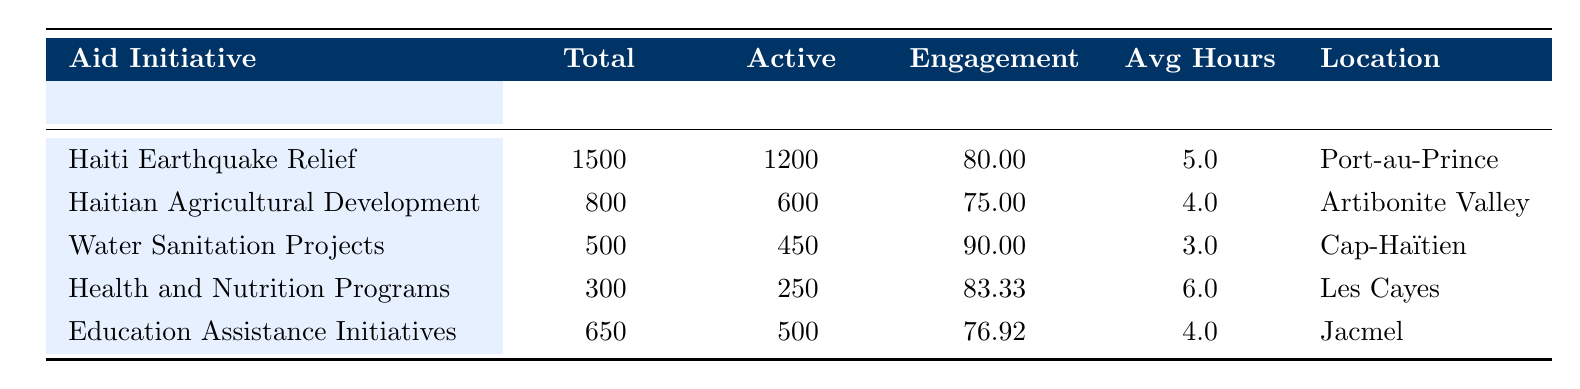What is the engagement rate of the Water Sanitation Projects? Referring to the table, the engagement rate for the Water Sanitation Projects is listed directly under the "Engagement Rate (%)" column, which indicates a value of 90.00%.
Answer: 90.00 Which aid initiative has the highest number of total volunteers? Looking through the "Total Volunteers" column, the Haiti Earthquake Relief initiative has the highest number, with a total of 1500 volunteers.
Answer: Haiti Earthquake Relief What is the average number of active volunteers for the Health and Nutrition Programs and Education Assistance Initiatives combined? To find the average, we first add the active volunteers: 250 (Health and Nutrition Programs) + 500 (Education Assistance Initiatives) = 750. Then, we divide by 2, as there are two initiatives, resulting in 750 / 2 = 375.
Answer: 375 Is the average hours per week for volunteers in the Haitian Agricultural Development greater than that of the Haiti Earthquake Relief initiative? The average hours per week for Haitian Agricultural Development are 4.0, while for Haiti Earthquake Relief, it is 5.0. Hence, 4.0 is not greater than 5.0. Therefore, the statement is false.
Answer: No What is the difference in the engagement rates between the Health and Nutrition Programs and the Haitian Agricultural Development? The engagement rate for Health and Nutrition Programs is 83.33% and for Haitian Agricultural Development, it is 75.00%. The difference is calculated by subtracting: 83.33 - 75.00 = 8.33.
Answer: 8.33 Which location had the lowest total number of volunteers? Reviewing the "Total Volunteers" column, the Water Sanitation Projects has the lowest total with 500 volunteers compared to the other initiatives.
Answer: Cap-Haïtien 